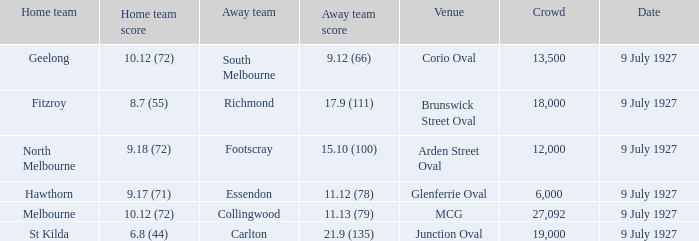What was the largest crowd where the home team was Fitzroy? 18000.0. 